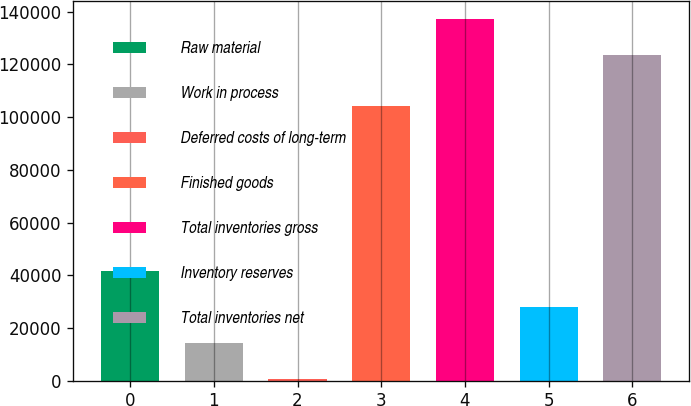<chart> <loc_0><loc_0><loc_500><loc_500><bar_chart><fcel>Raw material<fcel>Work in process<fcel>Deferred costs of long-term<fcel>Finished goods<fcel>Total inventories gross<fcel>Inventory reserves<fcel>Total inventories net<nl><fcel>41526.4<fcel>14244.8<fcel>604<fcel>104137<fcel>137012<fcel>27885.6<fcel>123357<nl></chart> 